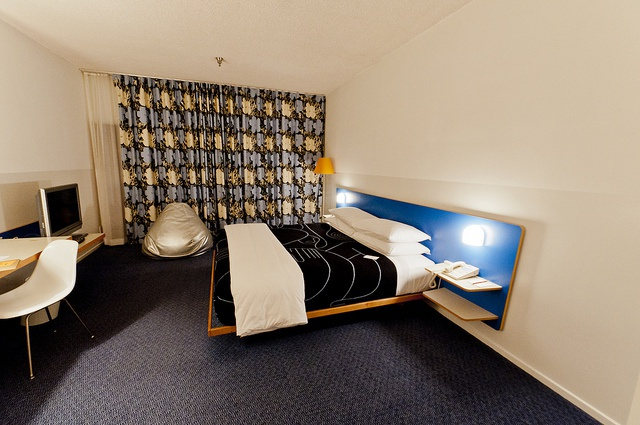Describe the objects in this image and their specific colors. I can see bed in beige, black, tan, and lightgray tones, chair in beige, black, ivory, and tan tones, and tv in beige, black, maroon, and gray tones in this image. 